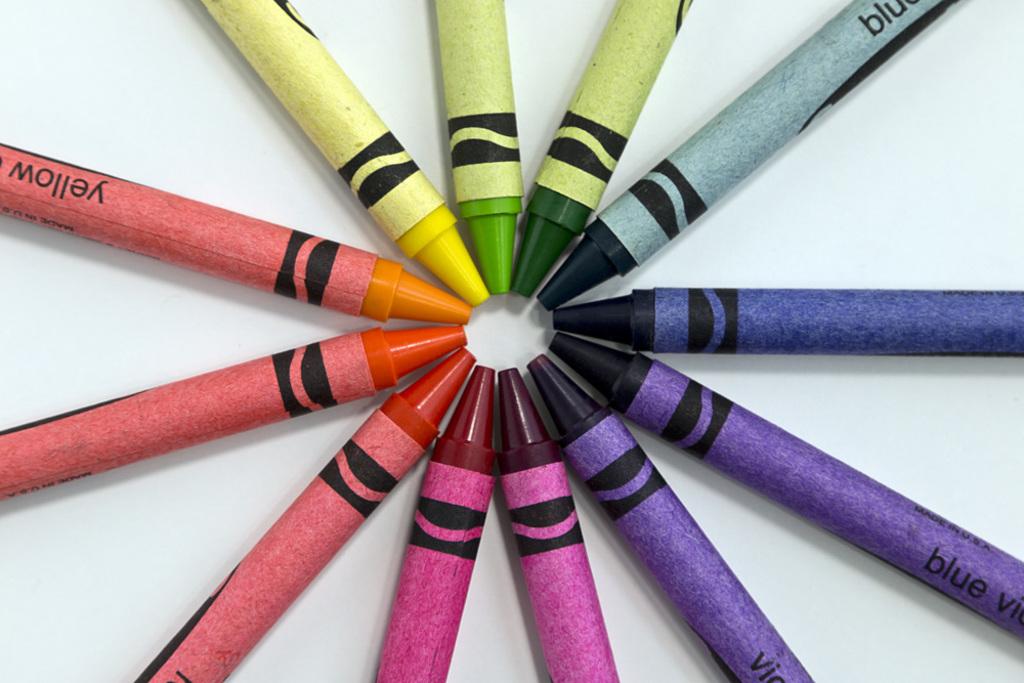Does it say yellow on the orange pencil?
Your answer should be very brief. Yes. This is colour pencle?
Offer a very short reply. No. 